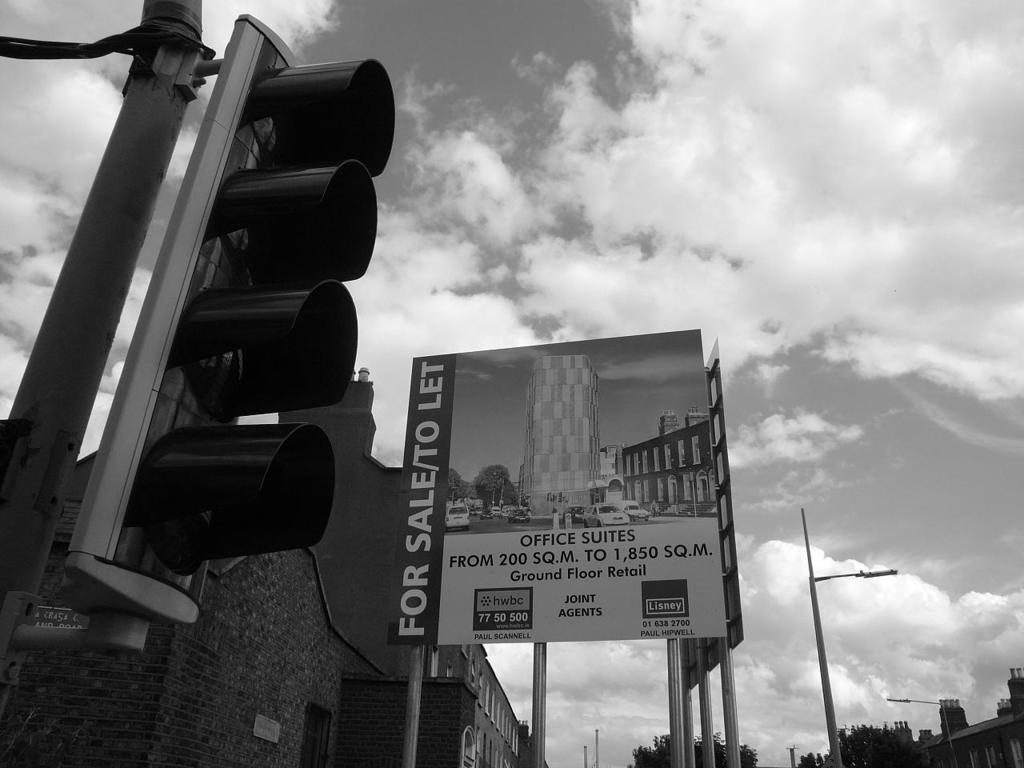Provide a one-sentence caption for the provided image. A black and white photo showing a sign for sale. 